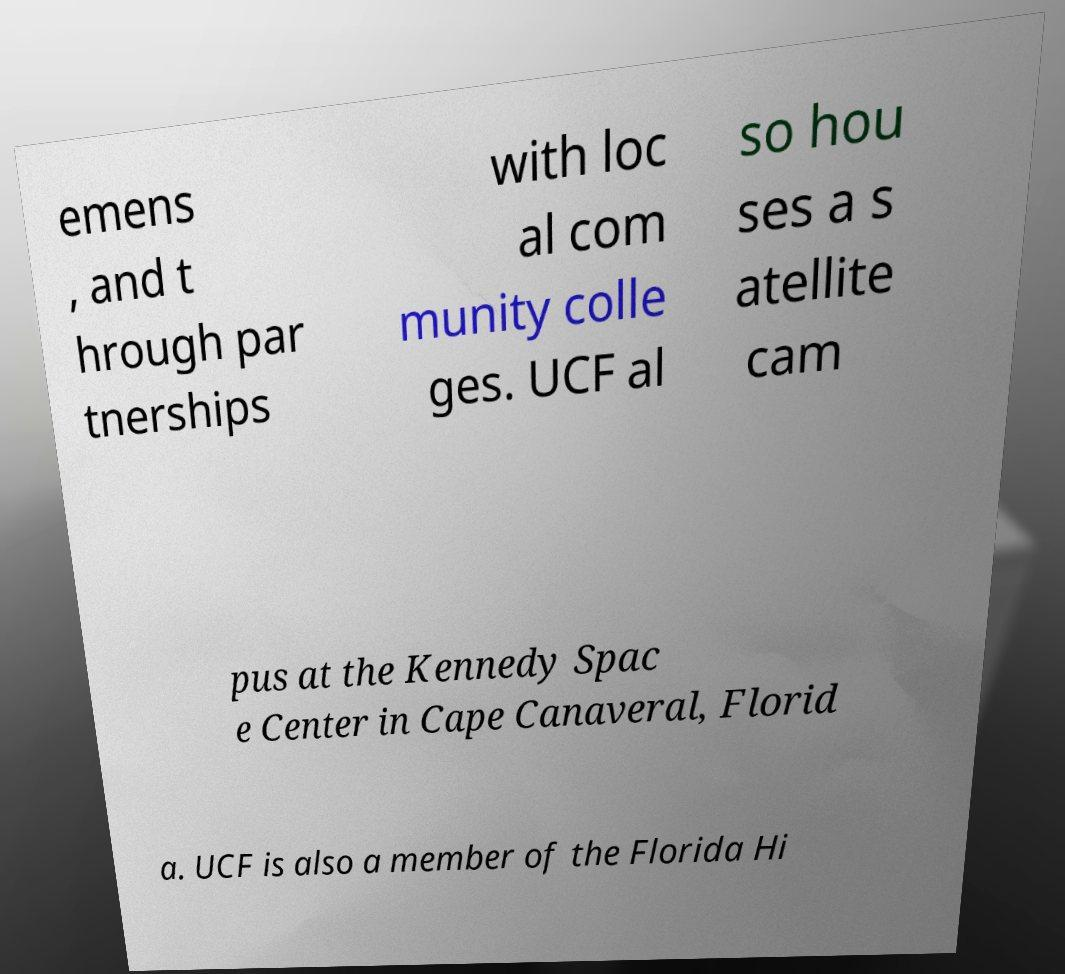Please read and relay the text visible in this image. What does it say? emens , and t hrough par tnerships with loc al com munity colle ges. UCF al so hou ses a s atellite cam pus at the Kennedy Spac e Center in Cape Canaveral, Florid a. UCF is also a member of the Florida Hi 